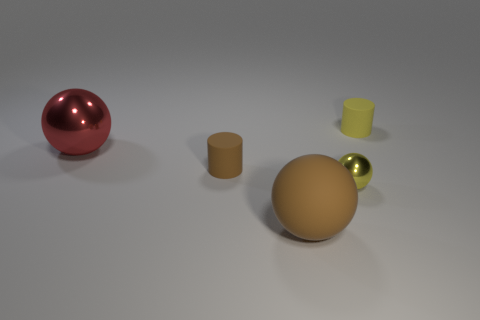The other object that is the same shape as the tiny brown thing is what color?
Provide a short and direct response. Yellow. Is there anything else that has the same shape as the large brown object?
Your answer should be very brief. Yes. There is a small brown matte thing; is its shape the same as the tiny object behind the big red shiny ball?
Offer a terse response. Yes. What is the material of the small yellow cylinder?
Offer a terse response. Rubber. What is the size of the other metallic thing that is the same shape as the red metallic object?
Your answer should be compact. Small. What number of other objects are the same material as the large brown object?
Keep it short and to the point. 2. Are the brown ball and the small object that is behind the red metallic object made of the same material?
Your response must be concise. Yes. Is the number of brown matte objects behind the big brown sphere less than the number of tiny yellow matte cylinders that are in front of the big metallic thing?
Offer a very short reply. No. There is a small cylinder left of the small yellow metal thing; what is its color?
Make the answer very short. Brown. How many other things are the same color as the large shiny sphere?
Provide a succinct answer. 0. 